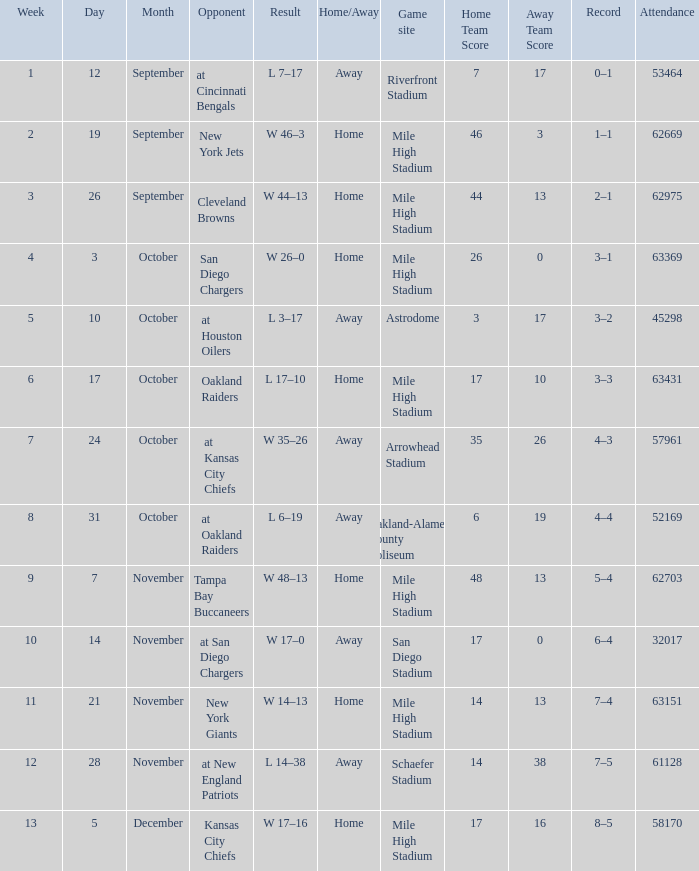What was the date of the week 4 game? October 3. 